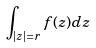Convert formula to latex. <formula><loc_0><loc_0><loc_500><loc_500>\int _ { | z | = r } f ( z ) d z</formula> 